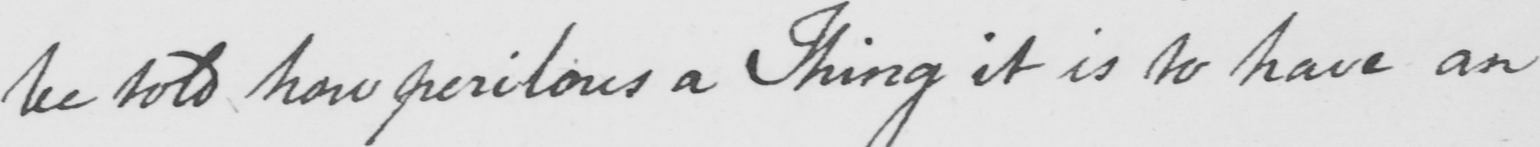Can you read and transcribe this handwriting? be told how perilous a Thing it is to have an 